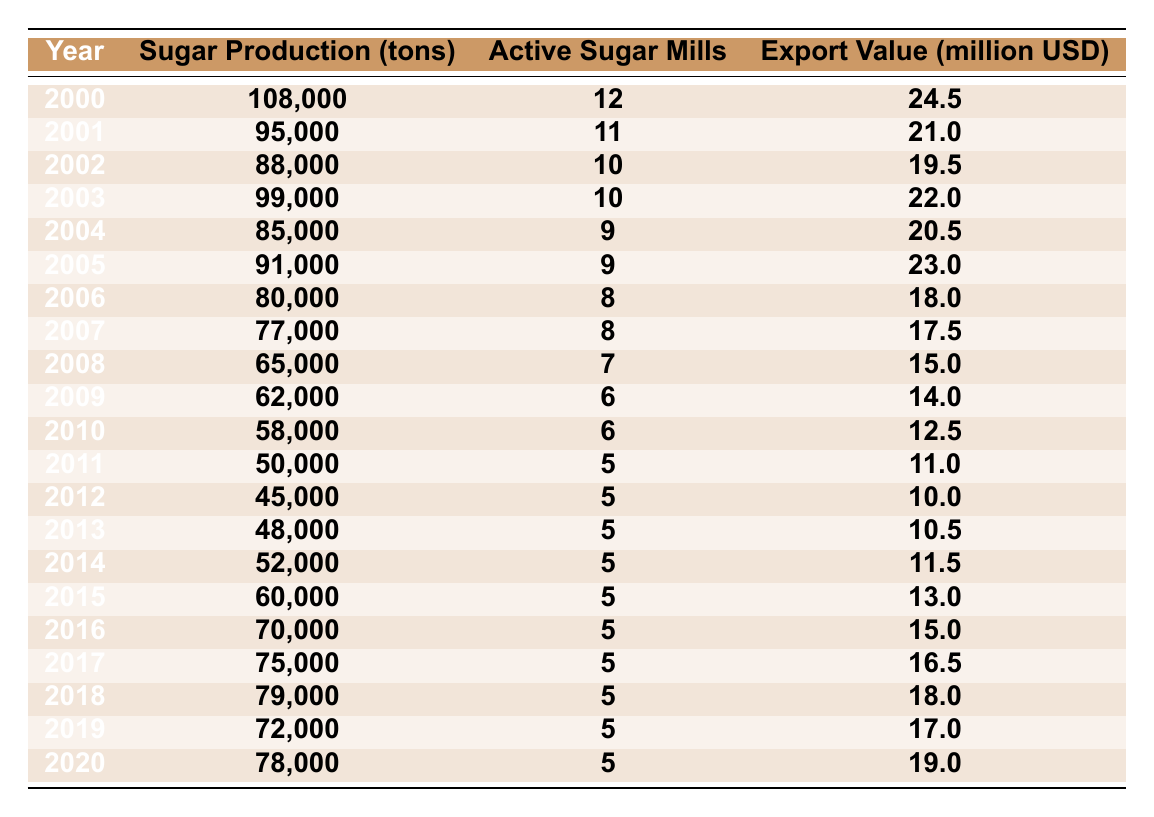What was the highest sugar production recorded in the table? By reviewing the sugar production values for each year, the highest figure is 108,000 tons in the year 2000.
Answer: 108,000 tons In which year did the number of active sugar mills drop to its lowest? Looking at the column for active sugar mills, the lowest value is 5, which occurs from 2011 through to 2020.
Answer: 2011 to 2020 What is the total sugar production from 2000 to 2020? Adding all the sugar production values from each year gives: 108000 + 95000 + 88000 + 99000 + 85000 + 91000 + 80000 + 77000 + 65000 + 62000 + 58000 + 50000 + 45000 + 48000 + 52000 + 60000 + 70000 + 75000 + 79000 + 72000 + 78000 = 1,390,000 tons.
Answer: 1,390,000 tons Did sugar production increase from 2015 to 2016? In 2015, sugar production was 60,000 tons, and in 2016 it was 70,000 tons. Since 70,000 is greater than 60,000, production increased.
Answer: Yes What was the average export value from 2010 to 2020? The export values from 2010 to 2020 are: 12.5, 11.0, 10.0, 10.5, 11.5, 13.0, 15.0, 16.5, 18.0, 17.0, and 19.0. Summing these values gives 134.5. There are 11 years in this range, so the average is 134.5/11 ≈ 12.23 million USD.
Answer: Approximately 12.23 million USD Which year had the greatest decrease in sugar production compared to the previous year? By comparing each year with the previous one, the largest drop occurs from 2001 to 2002, where production decreases from 95,000 tons to 88,000 tons, a drop of 7,000 tons.
Answer: 2001 to 2002 In what year was the export value the lowest? Reviewing the export value column, the lowest value recorded is 10.0 million USD in the year 2012.
Answer: 2012 How many tons of sugar were produced in total during the years when there were 5 active sugar mills? The years with 5 active sugar mills are from 2011 to 2020. The sugar production for these years is: 50,000 + 45,000 + 48,000 + 52,000 + 60,000 + 70,000 + 75,000 + 79,000 + 72,000 + 78,000, totaling 485,000 tons.
Answer: 485,000 tons Was there any year from 2000 to 2020 where sugar production exceeded 100,000 tons? Only in the year 2000 was sugar production greater than 100,000 tons, with a production of 108,000 tons. So yes, there was a year when it exceeded that amount.
Answer: Yes How much did the export value change from 2000 to 2020? The export value in 2000 was 24.5 million USD, and it was 19.0 million USD in 2020. So the change is 19.0 - 24.5 = -5.5 million USD, indicating a decrease.
Answer: Decrease of 5.5 million USD What was the sugar production trend from 2000 to 2020? Observing the values, sugar production generally started high in 2000 but saw a declining trend until 2014, then a slight increase happened from 2015 to 2020, indicating a recovery from a long-term decrease.
Answer: Declining trend with a slight recovery from 2015 to 2020 